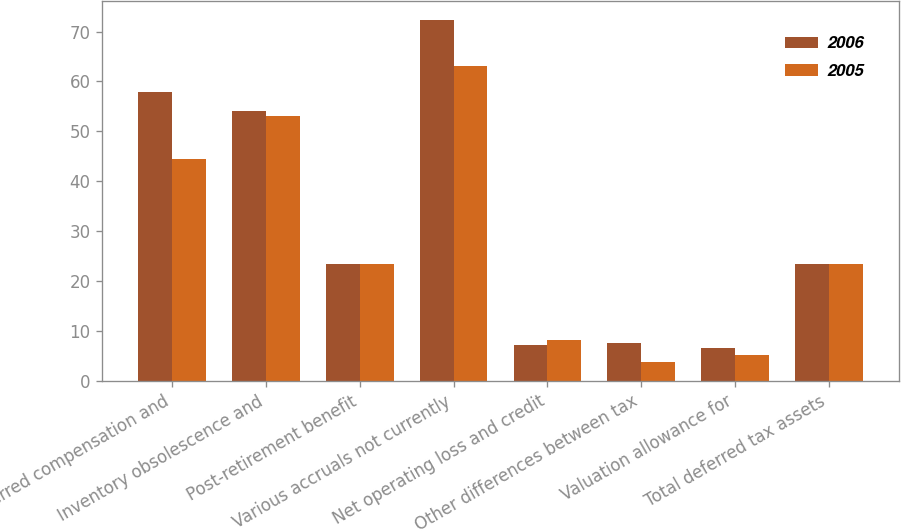<chart> <loc_0><loc_0><loc_500><loc_500><stacked_bar_chart><ecel><fcel>Deferred compensation and<fcel>Inventory obsolescence and<fcel>Post-retirement benefit<fcel>Various accruals not currently<fcel>Net operating loss and credit<fcel>Other differences between tax<fcel>Valuation allowance for<fcel>Total deferred tax assets<nl><fcel>2006<fcel>57.9<fcel>54<fcel>23.3<fcel>72.4<fcel>7.2<fcel>7.6<fcel>6.5<fcel>23.3<nl><fcel>2005<fcel>44.4<fcel>53<fcel>23.3<fcel>63.1<fcel>8.2<fcel>3.7<fcel>5.1<fcel>23.3<nl></chart> 